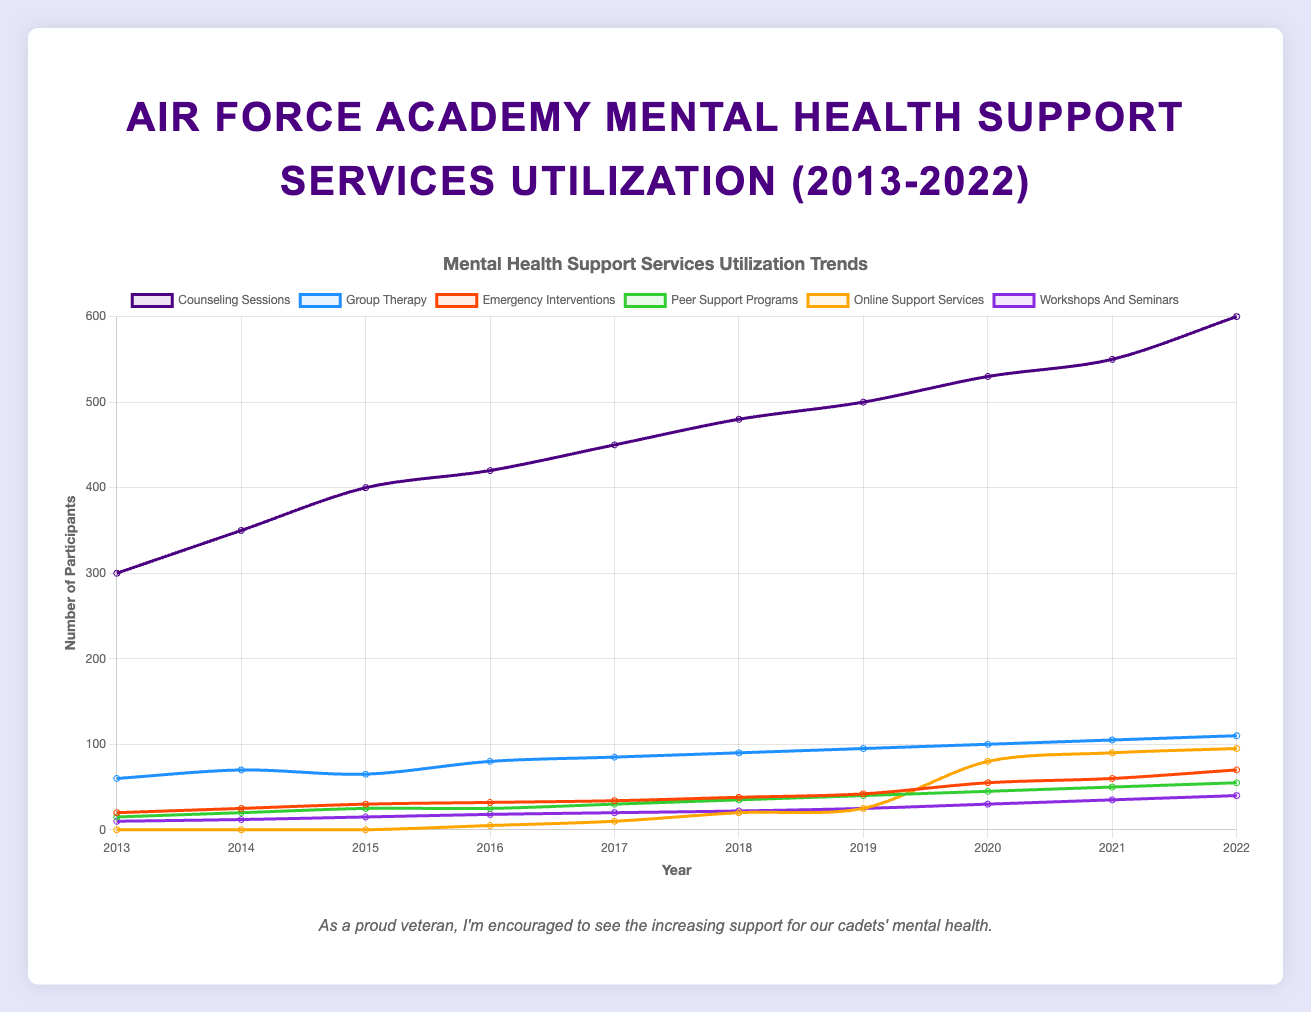Which mental health support service saw the highest utilization in 2022? To determine which mental health support service had the highest utilization in 2022, look at the data for that year across all services. Counseling Sessions had the highest number of participants at 600.
Answer: Counseling Sessions What was the percentage increase in Group Therapy utilization from 2013 to 2022? First, find the initial value in 2013 (60) and the final value in 2022 (110). The percentage increase is calculated as ((110 - 60) / 60) * 100. The result is approximately 83.33%.
Answer: 83.33% Which service shows the most significant increase in utilization from 2019 to 2020? Comparing the data for all services between 2019 and 2020, Online Support Services show the largest increase, going from 25 participants in 2019 to 80 in 2020, an increase of 55 participants.
Answer: Online Support Services How many services had an increase in utilization every year from 2017 to 2022? Looking at the data for each service from 2017 to 2022, Counseling Sessions, Group Therapy, Peer Support Programs, and Workshops and Seminars all show consistent increases each year. Thus, 4 services met this criterion.
Answer: 4 Between 2016 and 2018, which service had the least average number of participants? Calculate the average for each service over 2016, 2017, and 2018. Peer Support Programs had an average of (25+30+35)/3 = 30, which is the lowest compared to the other services' average values.
Answer: Peer Support Programs Which year had the highest total utilization of all services combined? Sum the values for each year. The year 2022 had the highest total utilization: 600 + 110 + 70 + 55 + 95 + 40 = 970.
Answer: 2022 In which years did Emergency Interventions exceed Peer Support Programs in utilization? Compare the values for Emergency Interventions and Peer Support Programs year by year. Emergency Interventions exceeded Peer Support Programs in 2013, 2014, 2015, 2017, 2018, 2019, 2020, 2021, and 2022.
Answer: 9 years What was the average utilization of Online Support Services from 2016 to 2022? Calculate the average utilization over the years 2016 to 2022 for Online Support Services: (5+10+20+25+80+90+95)/7 = 46.43.
Answer: 46.43 Which service had the smallest increase in participants from 2018 to 2019? Calculate the increase for each service between 2018 and 2019. Peer Support Programs increased from 35 to 40, which is the smallest increase of 5 participants.
Answer: Peer Support Programs 